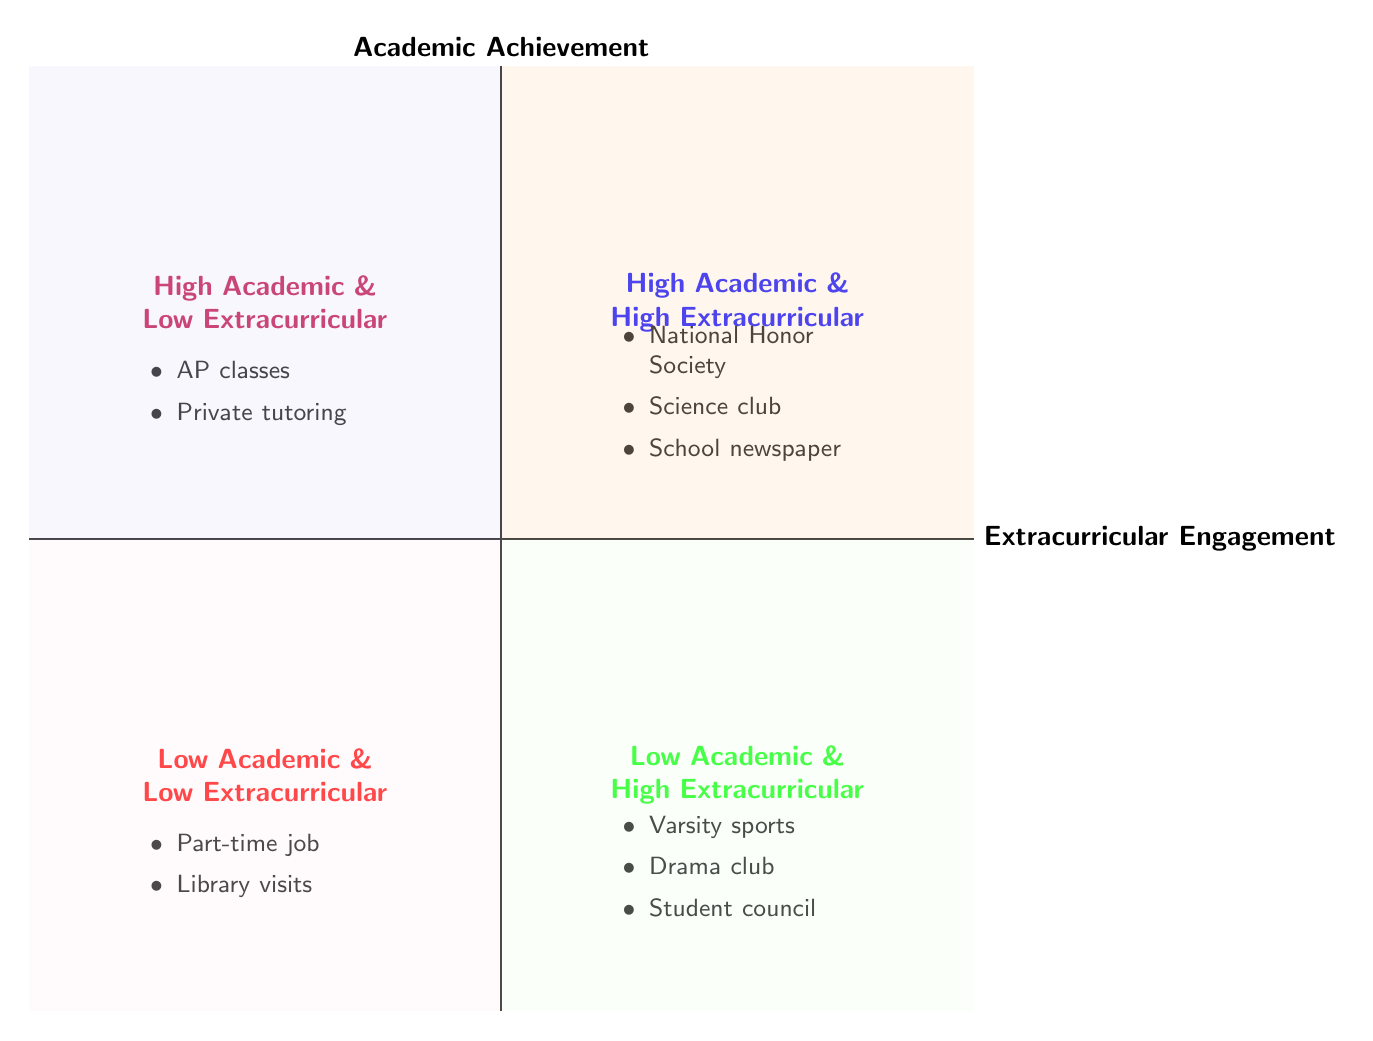What activities are listed under High Academic & High Extracurricular? The quadrant labeled "High Academic & High Extracurricular" contains three activities: National Honor Society membership, Science club participation, and School newspaper editorial role, which can be directly read from the quadrant.
Answer: National Honor Society membership, Science club participation, School newspaper editorial role How many activities are listed in Low Academic & Low Extracurricular? In the "Low Academic & Low Extracurricular" quadrant, there are two activities: Part-time job and Frequent library visits. Counting these activities gives a total of two.
Answer: 2 What is the relationship between High Academic Achievement and extracurricular activities? The diagram shows that students with high academic achievement tend to engage more in extracurricular activities, as indicated by the activities listed in both the High Extracurricular Engagement quadrant and the High Academic Achievement quadrant.
Answer: Positive relationship Which quadrant contains students involved in varsity sports? The activity "Varsity sports involvement" is listed in the "Low Academic & High Extracurricular" quadrant, as seen when referencing the activities provided in that section of the diagram.
Answer: Low Academic & High Extracurricular What does the Low Academic & Low Extracurricular quadrant suggest about the impact of library visits? The activities in the "Low Academic & Low Extracurricular" quadrant include "Frequent library visits," which indicates that frequent visits to the library alone may not contribute significantly to academic achievement in this context.
Answer: Limited impact Which group shows the highest combination of extracurricular engagement and academic achievement? The diagram indicates that the group titled "High Academic & High Extracurricular" showcases the highest combination of both extracurricular engagement and academic achievement based on the activities presented in that quadrant.
Answer: High Academic & High Extracurricular 